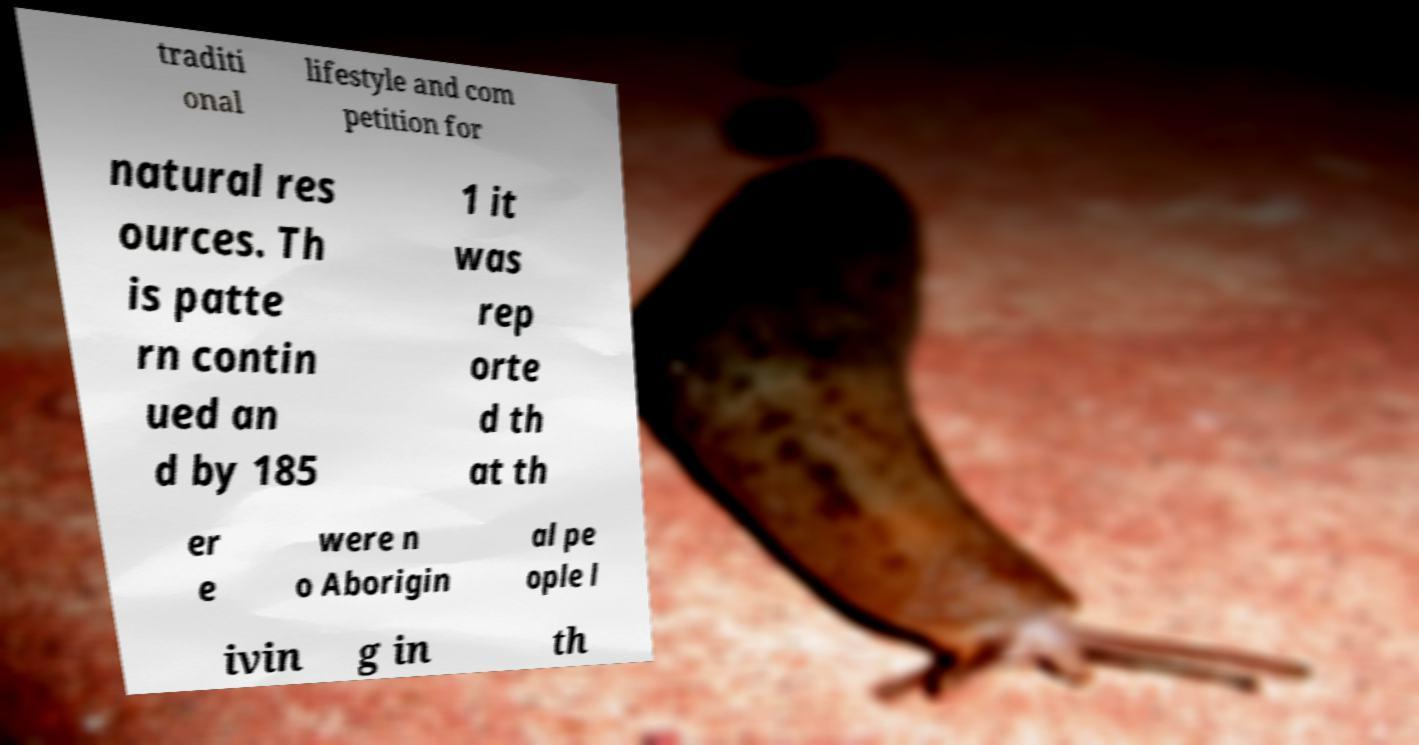Can you read and provide the text displayed in the image?This photo seems to have some interesting text. Can you extract and type it out for me? traditi onal lifestyle and com petition for natural res ources. Th is patte rn contin ued an d by 185 1 it was rep orte d th at th er e were n o Aborigin al pe ople l ivin g in th 